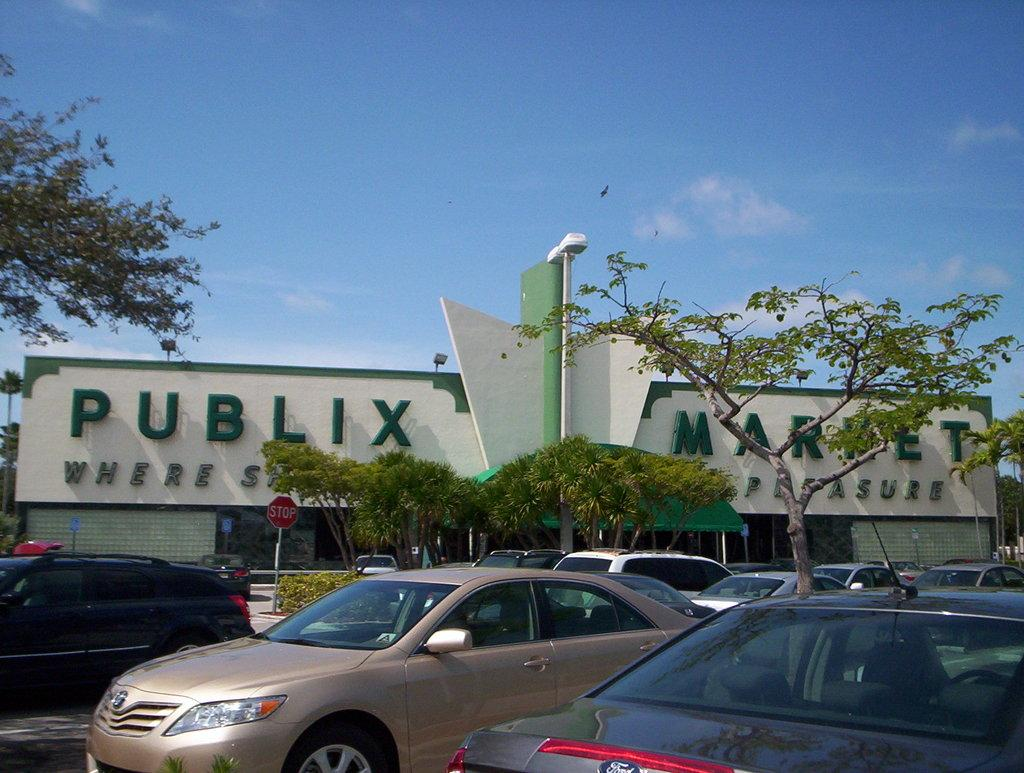What can be seen in the foreground of the image? There are cars in the foreground of the image. What is located in the middle of the image? There is a building in the middle of the image, and there are trees as well. What is written or displayed on the building? There is text on the building. What is visible at the top of the image? The sky is visible at the top of the image. Can you see a wrench being used on the cars in the image? There is no wrench present in the image, nor is any tool being used on the cars. How many trains are visible in the image? There are no trains present in the image. 